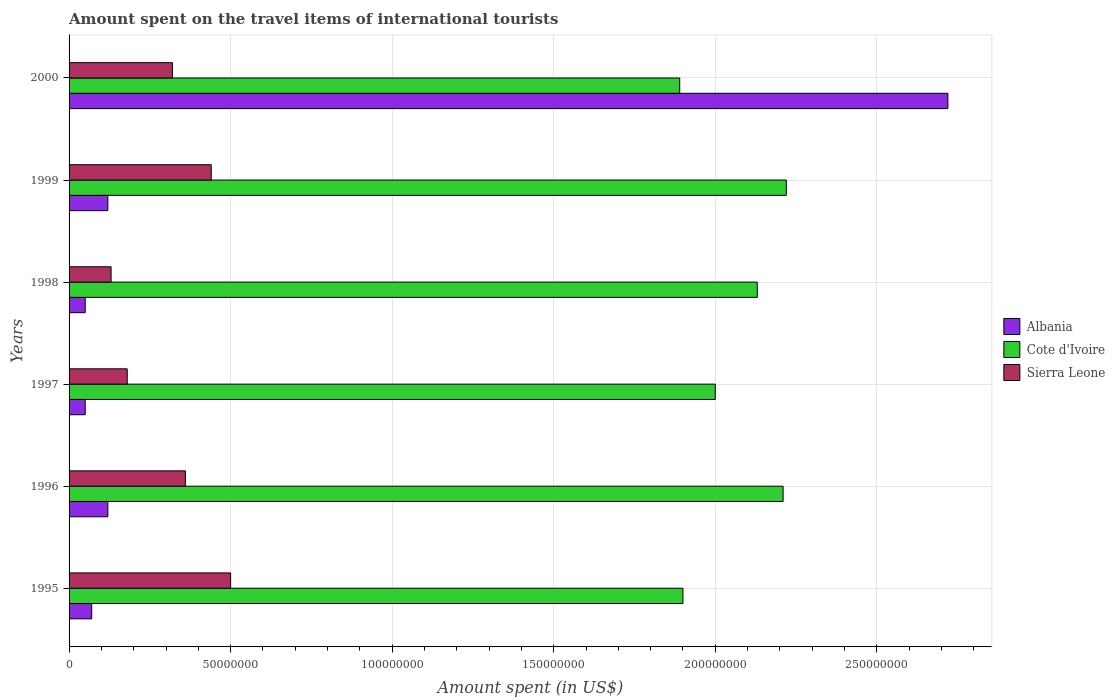How many groups of bars are there?
Your response must be concise. 6. Are the number of bars per tick equal to the number of legend labels?
Your response must be concise. Yes. How many bars are there on the 6th tick from the top?
Ensure brevity in your answer.  3. How many bars are there on the 3rd tick from the bottom?
Provide a short and direct response. 3. What is the label of the 5th group of bars from the top?
Provide a short and direct response. 1996. What is the amount spent on the travel items of international tourists in Cote d'Ivoire in 1998?
Your answer should be compact. 2.13e+08. Across all years, what is the maximum amount spent on the travel items of international tourists in Cote d'Ivoire?
Offer a terse response. 2.22e+08. Across all years, what is the minimum amount spent on the travel items of international tourists in Albania?
Your answer should be compact. 5.00e+06. What is the total amount spent on the travel items of international tourists in Cote d'Ivoire in the graph?
Make the answer very short. 1.24e+09. What is the difference between the amount spent on the travel items of international tourists in Sierra Leone in 1997 and that in 1999?
Give a very brief answer. -2.60e+07. What is the difference between the amount spent on the travel items of international tourists in Albania in 2000 and the amount spent on the travel items of international tourists in Cote d'Ivoire in 1995?
Keep it short and to the point. 8.20e+07. What is the average amount spent on the travel items of international tourists in Cote d'Ivoire per year?
Make the answer very short. 2.06e+08. In the year 1997, what is the difference between the amount spent on the travel items of international tourists in Albania and amount spent on the travel items of international tourists in Cote d'Ivoire?
Keep it short and to the point. -1.95e+08. In how many years, is the amount spent on the travel items of international tourists in Cote d'Ivoire greater than 160000000 US$?
Keep it short and to the point. 6. What is the ratio of the amount spent on the travel items of international tourists in Sierra Leone in 1996 to that in 1999?
Keep it short and to the point. 0.82. Is the amount spent on the travel items of international tourists in Albania in 1996 less than that in 1997?
Your answer should be compact. No. Is the difference between the amount spent on the travel items of international tourists in Albania in 1997 and 1998 greater than the difference between the amount spent on the travel items of international tourists in Cote d'Ivoire in 1997 and 1998?
Give a very brief answer. Yes. What is the difference between the highest and the second highest amount spent on the travel items of international tourists in Albania?
Your answer should be very brief. 2.60e+08. What is the difference between the highest and the lowest amount spent on the travel items of international tourists in Albania?
Give a very brief answer. 2.67e+08. In how many years, is the amount spent on the travel items of international tourists in Cote d'Ivoire greater than the average amount spent on the travel items of international tourists in Cote d'Ivoire taken over all years?
Your answer should be compact. 3. What does the 3rd bar from the top in 1999 represents?
Your answer should be compact. Albania. What does the 3rd bar from the bottom in 2000 represents?
Your response must be concise. Sierra Leone. Is it the case that in every year, the sum of the amount spent on the travel items of international tourists in Sierra Leone and amount spent on the travel items of international tourists in Albania is greater than the amount spent on the travel items of international tourists in Cote d'Ivoire?
Offer a very short reply. No. Are all the bars in the graph horizontal?
Your answer should be compact. Yes. How many years are there in the graph?
Ensure brevity in your answer.  6. Does the graph contain any zero values?
Offer a very short reply. No. How many legend labels are there?
Keep it short and to the point. 3. How are the legend labels stacked?
Your response must be concise. Vertical. What is the title of the graph?
Make the answer very short. Amount spent on the travel items of international tourists. Does "Philippines" appear as one of the legend labels in the graph?
Your answer should be compact. No. What is the label or title of the X-axis?
Your response must be concise. Amount spent (in US$). What is the Amount spent (in US$) of Cote d'Ivoire in 1995?
Provide a short and direct response. 1.90e+08. What is the Amount spent (in US$) of Cote d'Ivoire in 1996?
Give a very brief answer. 2.21e+08. What is the Amount spent (in US$) of Sierra Leone in 1996?
Your response must be concise. 3.60e+07. What is the Amount spent (in US$) in Cote d'Ivoire in 1997?
Make the answer very short. 2.00e+08. What is the Amount spent (in US$) in Sierra Leone in 1997?
Your answer should be compact. 1.80e+07. What is the Amount spent (in US$) in Cote d'Ivoire in 1998?
Ensure brevity in your answer.  2.13e+08. What is the Amount spent (in US$) in Sierra Leone in 1998?
Offer a very short reply. 1.30e+07. What is the Amount spent (in US$) in Albania in 1999?
Your response must be concise. 1.20e+07. What is the Amount spent (in US$) in Cote d'Ivoire in 1999?
Give a very brief answer. 2.22e+08. What is the Amount spent (in US$) in Sierra Leone in 1999?
Ensure brevity in your answer.  4.40e+07. What is the Amount spent (in US$) in Albania in 2000?
Make the answer very short. 2.72e+08. What is the Amount spent (in US$) in Cote d'Ivoire in 2000?
Provide a short and direct response. 1.89e+08. What is the Amount spent (in US$) of Sierra Leone in 2000?
Provide a short and direct response. 3.20e+07. Across all years, what is the maximum Amount spent (in US$) in Albania?
Provide a succinct answer. 2.72e+08. Across all years, what is the maximum Amount spent (in US$) of Cote d'Ivoire?
Give a very brief answer. 2.22e+08. Across all years, what is the minimum Amount spent (in US$) in Cote d'Ivoire?
Your answer should be compact. 1.89e+08. Across all years, what is the minimum Amount spent (in US$) of Sierra Leone?
Ensure brevity in your answer.  1.30e+07. What is the total Amount spent (in US$) in Albania in the graph?
Provide a short and direct response. 3.13e+08. What is the total Amount spent (in US$) of Cote d'Ivoire in the graph?
Your answer should be compact. 1.24e+09. What is the total Amount spent (in US$) of Sierra Leone in the graph?
Make the answer very short. 1.93e+08. What is the difference between the Amount spent (in US$) in Albania in 1995 and that in 1996?
Your response must be concise. -5.00e+06. What is the difference between the Amount spent (in US$) in Cote d'Ivoire in 1995 and that in 1996?
Offer a terse response. -3.10e+07. What is the difference between the Amount spent (in US$) in Sierra Leone in 1995 and that in 1996?
Your answer should be compact. 1.40e+07. What is the difference between the Amount spent (in US$) in Cote d'Ivoire in 1995 and that in 1997?
Keep it short and to the point. -1.00e+07. What is the difference between the Amount spent (in US$) of Sierra Leone in 1995 and that in 1997?
Offer a terse response. 3.20e+07. What is the difference between the Amount spent (in US$) in Albania in 1995 and that in 1998?
Your response must be concise. 2.00e+06. What is the difference between the Amount spent (in US$) in Cote d'Ivoire in 1995 and that in 1998?
Keep it short and to the point. -2.30e+07. What is the difference between the Amount spent (in US$) in Sierra Leone in 1995 and that in 1998?
Offer a very short reply. 3.70e+07. What is the difference between the Amount spent (in US$) in Albania in 1995 and that in 1999?
Ensure brevity in your answer.  -5.00e+06. What is the difference between the Amount spent (in US$) in Cote d'Ivoire in 1995 and that in 1999?
Ensure brevity in your answer.  -3.20e+07. What is the difference between the Amount spent (in US$) in Albania in 1995 and that in 2000?
Give a very brief answer. -2.65e+08. What is the difference between the Amount spent (in US$) of Sierra Leone in 1995 and that in 2000?
Offer a very short reply. 1.80e+07. What is the difference between the Amount spent (in US$) in Albania in 1996 and that in 1997?
Your answer should be very brief. 7.00e+06. What is the difference between the Amount spent (in US$) in Cote d'Ivoire in 1996 and that in 1997?
Offer a terse response. 2.10e+07. What is the difference between the Amount spent (in US$) of Sierra Leone in 1996 and that in 1997?
Provide a short and direct response. 1.80e+07. What is the difference between the Amount spent (in US$) in Albania in 1996 and that in 1998?
Offer a very short reply. 7.00e+06. What is the difference between the Amount spent (in US$) in Sierra Leone in 1996 and that in 1998?
Your answer should be compact. 2.30e+07. What is the difference between the Amount spent (in US$) of Albania in 1996 and that in 1999?
Offer a terse response. 0. What is the difference between the Amount spent (in US$) in Cote d'Ivoire in 1996 and that in 1999?
Keep it short and to the point. -1.00e+06. What is the difference between the Amount spent (in US$) of Sierra Leone in 1996 and that in 1999?
Your response must be concise. -8.00e+06. What is the difference between the Amount spent (in US$) in Albania in 1996 and that in 2000?
Ensure brevity in your answer.  -2.60e+08. What is the difference between the Amount spent (in US$) of Cote d'Ivoire in 1996 and that in 2000?
Your answer should be very brief. 3.20e+07. What is the difference between the Amount spent (in US$) in Sierra Leone in 1996 and that in 2000?
Provide a short and direct response. 4.00e+06. What is the difference between the Amount spent (in US$) in Albania in 1997 and that in 1998?
Give a very brief answer. 0. What is the difference between the Amount spent (in US$) in Cote d'Ivoire in 1997 and that in 1998?
Your answer should be compact. -1.30e+07. What is the difference between the Amount spent (in US$) of Sierra Leone in 1997 and that in 1998?
Your answer should be compact. 5.00e+06. What is the difference between the Amount spent (in US$) of Albania in 1997 and that in 1999?
Your answer should be very brief. -7.00e+06. What is the difference between the Amount spent (in US$) in Cote d'Ivoire in 1997 and that in 1999?
Give a very brief answer. -2.20e+07. What is the difference between the Amount spent (in US$) of Sierra Leone in 1997 and that in 1999?
Offer a very short reply. -2.60e+07. What is the difference between the Amount spent (in US$) in Albania in 1997 and that in 2000?
Your answer should be compact. -2.67e+08. What is the difference between the Amount spent (in US$) in Cote d'Ivoire in 1997 and that in 2000?
Give a very brief answer. 1.10e+07. What is the difference between the Amount spent (in US$) in Sierra Leone in 1997 and that in 2000?
Provide a short and direct response. -1.40e+07. What is the difference between the Amount spent (in US$) of Albania in 1998 and that in 1999?
Offer a terse response. -7.00e+06. What is the difference between the Amount spent (in US$) of Cote d'Ivoire in 1998 and that in 1999?
Make the answer very short. -9.00e+06. What is the difference between the Amount spent (in US$) in Sierra Leone in 1998 and that in 1999?
Ensure brevity in your answer.  -3.10e+07. What is the difference between the Amount spent (in US$) of Albania in 1998 and that in 2000?
Offer a terse response. -2.67e+08. What is the difference between the Amount spent (in US$) in Cote d'Ivoire in 1998 and that in 2000?
Provide a short and direct response. 2.40e+07. What is the difference between the Amount spent (in US$) in Sierra Leone in 1998 and that in 2000?
Keep it short and to the point. -1.90e+07. What is the difference between the Amount spent (in US$) of Albania in 1999 and that in 2000?
Provide a short and direct response. -2.60e+08. What is the difference between the Amount spent (in US$) of Cote d'Ivoire in 1999 and that in 2000?
Provide a succinct answer. 3.30e+07. What is the difference between the Amount spent (in US$) in Sierra Leone in 1999 and that in 2000?
Provide a succinct answer. 1.20e+07. What is the difference between the Amount spent (in US$) of Albania in 1995 and the Amount spent (in US$) of Cote d'Ivoire in 1996?
Ensure brevity in your answer.  -2.14e+08. What is the difference between the Amount spent (in US$) in Albania in 1995 and the Amount spent (in US$) in Sierra Leone in 1996?
Your answer should be very brief. -2.90e+07. What is the difference between the Amount spent (in US$) in Cote d'Ivoire in 1995 and the Amount spent (in US$) in Sierra Leone in 1996?
Provide a short and direct response. 1.54e+08. What is the difference between the Amount spent (in US$) of Albania in 1995 and the Amount spent (in US$) of Cote d'Ivoire in 1997?
Offer a terse response. -1.93e+08. What is the difference between the Amount spent (in US$) in Albania in 1995 and the Amount spent (in US$) in Sierra Leone in 1997?
Your answer should be compact. -1.10e+07. What is the difference between the Amount spent (in US$) in Cote d'Ivoire in 1995 and the Amount spent (in US$) in Sierra Leone in 1997?
Keep it short and to the point. 1.72e+08. What is the difference between the Amount spent (in US$) in Albania in 1995 and the Amount spent (in US$) in Cote d'Ivoire in 1998?
Your answer should be compact. -2.06e+08. What is the difference between the Amount spent (in US$) of Albania in 1995 and the Amount spent (in US$) of Sierra Leone in 1998?
Your answer should be very brief. -6.00e+06. What is the difference between the Amount spent (in US$) in Cote d'Ivoire in 1995 and the Amount spent (in US$) in Sierra Leone in 1998?
Give a very brief answer. 1.77e+08. What is the difference between the Amount spent (in US$) in Albania in 1995 and the Amount spent (in US$) in Cote d'Ivoire in 1999?
Offer a very short reply. -2.15e+08. What is the difference between the Amount spent (in US$) in Albania in 1995 and the Amount spent (in US$) in Sierra Leone in 1999?
Provide a succinct answer. -3.70e+07. What is the difference between the Amount spent (in US$) of Cote d'Ivoire in 1995 and the Amount spent (in US$) of Sierra Leone in 1999?
Make the answer very short. 1.46e+08. What is the difference between the Amount spent (in US$) in Albania in 1995 and the Amount spent (in US$) in Cote d'Ivoire in 2000?
Provide a succinct answer. -1.82e+08. What is the difference between the Amount spent (in US$) of Albania in 1995 and the Amount spent (in US$) of Sierra Leone in 2000?
Give a very brief answer. -2.50e+07. What is the difference between the Amount spent (in US$) of Cote d'Ivoire in 1995 and the Amount spent (in US$) of Sierra Leone in 2000?
Your answer should be very brief. 1.58e+08. What is the difference between the Amount spent (in US$) of Albania in 1996 and the Amount spent (in US$) of Cote d'Ivoire in 1997?
Your answer should be compact. -1.88e+08. What is the difference between the Amount spent (in US$) in Albania in 1996 and the Amount spent (in US$) in Sierra Leone in 1997?
Your answer should be very brief. -6.00e+06. What is the difference between the Amount spent (in US$) of Cote d'Ivoire in 1996 and the Amount spent (in US$) of Sierra Leone in 1997?
Make the answer very short. 2.03e+08. What is the difference between the Amount spent (in US$) of Albania in 1996 and the Amount spent (in US$) of Cote d'Ivoire in 1998?
Give a very brief answer. -2.01e+08. What is the difference between the Amount spent (in US$) in Albania in 1996 and the Amount spent (in US$) in Sierra Leone in 1998?
Offer a terse response. -1.00e+06. What is the difference between the Amount spent (in US$) of Cote d'Ivoire in 1996 and the Amount spent (in US$) of Sierra Leone in 1998?
Make the answer very short. 2.08e+08. What is the difference between the Amount spent (in US$) of Albania in 1996 and the Amount spent (in US$) of Cote d'Ivoire in 1999?
Provide a succinct answer. -2.10e+08. What is the difference between the Amount spent (in US$) in Albania in 1996 and the Amount spent (in US$) in Sierra Leone in 1999?
Offer a terse response. -3.20e+07. What is the difference between the Amount spent (in US$) in Cote d'Ivoire in 1996 and the Amount spent (in US$) in Sierra Leone in 1999?
Offer a terse response. 1.77e+08. What is the difference between the Amount spent (in US$) of Albania in 1996 and the Amount spent (in US$) of Cote d'Ivoire in 2000?
Provide a succinct answer. -1.77e+08. What is the difference between the Amount spent (in US$) of Albania in 1996 and the Amount spent (in US$) of Sierra Leone in 2000?
Your answer should be compact. -2.00e+07. What is the difference between the Amount spent (in US$) in Cote d'Ivoire in 1996 and the Amount spent (in US$) in Sierra Leone in 2000?
Ensure brevity in your answer.  1.89e+08. What is the difference between the Amount spent (in US$) in Albania in 1997 and the Amount spent (in US$) in Cote d'Ivoire in 1998?
Provide a succinct answer. -2.08e+08. What is the difference between the Amount spent (in US$) of Albania in 1997 and the Amount spent (in US$) of Sierra Leone in 1998?
Ensure brevity in your answer.  -8.00e+06. What is the difference between the Amount spent (in US$) in Cote d'Ivoire in 1997 and the Amount spent (in US$) in Sierra Leone in 1998?
Your answer should be compact. 1.87e+08. What is the difference between the Amount spent (in US$) of Albania in 1997 and the Amount spent (in US$) of Cote d'Ivoire in 1999?
Offer a very short reply. -2.17e+08. What is the difference between the Amount spent (in US$) of Albania in 1997 and the Amount spent (in US$) of Sierra Leone in 1999?
Your answer should be compact. -3.90e+07. What is the difference between the Amount spent (in US$) in Cote d'Ivoire in 1997 and the Amount spent (in US$) in Sierra Leone in 1999?
Provide a succinct answer. 1.56e+08. What is the difference between the Amount spent (in US$) in Albania in 1997 and the Amount spent (in US$) in Cote d'Ivoire in 2000?
Provide a succinct answer. -1.84e+08. What is the difference between the Amount spent (in US$) in Albania in 1997 and the Amount spent (in US$) in Sierra Leone in 2000?
Give a very brief answer. -2.70e+07. What is the difference between the Amount spent (in US$) of Cote d'Ivoire in 1997 and the Amount spent (in US$) of Sierra Leone in 2000?
Keep it short and to the point. 1.68e+08. What is the difference between the Amount spent (in US$) of Albania in 1998 and the Amount spent (in US$) of Cote d'Ivoire in 1999?
Give a very brief answer. -2.17e+08. What is the difference between the Amount spent (in US$) of Albania in 1998 and the Amount spent (in US$) of Sierra Leone in 1999?
Provide a short and direct response. -3.90e+07. What is the difference between the Amount spent (in US$) in Cote d'Ivoire in 1998 and the Amount spent (in US$) in Sierra Leone in 1999?
Offer a very short reply. 1.69e+08. What is the difference between the Amount spent (in US$) in Albania in 1998 and the Amount spent (in US$) in Cote d'Ivoire in 2000?
Provide a short and direct response. -1.84e+08. What is the difference between the Amount spent (in US$) of Albania in 1998 and the Amount spent (in US$) of Sierra Leone in 2000?
Offer a very short reply. -2.70e+07. What is the difference between the Amount spent (in US$) in Cote d'Ivoire in 1998 and the Amount spent (in US$) in Sierra Leone in 2000?
Make the answer very short. 1.81e+08. What is the difference between the Amount spent (in US$) in Albania in 1999 and the Amount spent (in US$) in Cote d'Ivoire in 2000?
Make the answer very short. -1.77e+08. What is the difference between the Amount spent (in US$) of Albania in 1999 and the Amount spent (in US$) of Sierra Leone in 2000?
Your answer should be very brief. -2.00e+07. What is the difference between the Amount spent (in US$) of Cote d'Ivoire in 1999 and the Amount spent (in US$) of Sierra Leone in 2000?
Your answer should be compact. 1.90e+08. What is the average Amount spent (in US$) in Albania per year?
Give a very brief answer. 5.22e+07. What is the average Amount spent (in US$) in Cote d'Ivoire per year?
Your response must be concise. 2.06e+08. What is the average Amount spent (in US$) of Sierra Leone per year?
Offer a terse response. 3.22e+07. In the year 1995, what is the difference between the Amount spent (in US$) in Albania and Amount spent (in US$) in Cote d'Ivoire?
Your response must be concise. -1.83e+08. In the year 1995, what is the difference between the Amount spent (in US$) in Albania and Amount spent (in US$) in Sierra Leone?
Provide a succinct answer. -4.30e+07. In the year 1995, what is the difference between the Amount spent (in US$) in Cote d'Ivoire and Amount spent (in US$) in Sierra Leone?
Provide a succinct answer. 1.40e+08. In the year 1996, what is the difference between the Amount spent (in US$) of Albania and Amount spent (in US$) of Cote d'Ivoire?
Offer a very short reply. -2.09e+08. In the year 1996, what is the difference between the Amount spent (in US$) of Albania and Amount spent (in US$) of Sierra Leone?
Provide a succinct answer. -2.40e+07. In the year 1996, what is the difference between the Amount spent (in US$) in Cote d'Ivoire and Amount spent (in US$) in Sierra Leone?
Offer a very short reply. 1.85e+08. In the year 1997, what is the difference between the Amount spent (in US$) in Albania and Amount spent (in US$) in Cote d'Ivoire?
Provide a short and direct response. -1.95e+08. In the year 1997, what is the difference between the Amount spent (in US$) in Albania and Amount spent (in US$) in Sierra Leone?
Give a very brief answer. -1.30e+07. In the year 1997, what is the difference between the Amount spent (in US$) of Cote d'Ivoire and Amount spent (in US$) of Sierra Leone?
Keep it short and to the point. 1.82e+08. In the year 1998, what is the difference between the Amount spent (in US$) in Albania and Amount spent (in US$) in Cote d'Ivoire?
Give a very brief answer. -2.08e+08. In the year 1998, what is the difference between the Amount spent (in US$) of Albania and Amount spent (in US$) of Sierra Leone?
Offer a terse response. -8.00e+06. In the year 1998, what is the difference between the Amount spent (in US$) in Cote d'Ivoire and Amount spent (in US$) in Sierra Leone?
Ensure brevity in your answer.  2.00e+08. In the year 1999, what is the difference between the Amount spent (in US$) of Albania and Amount spent (in US$) of Cote d'Ivoire?
Provide a short and direct response. -2.10e+08. In the year 1999, what is the difference between the Amount spent (in US$) in Albania and Amount spent (in US$) in Sierra Leone?
Make the answer very short. -3.20e+07. In the year 1999, what is the difference between the Amount spent (in US$) in Cote d'Ivoire and Amount spent (in US$) in Sierra Leone?
Your answer should be compact. 1.78e+08. In the year 2000, what is the difference between the Amount spent (in US$) in Albania and Amount spent (in US$) in Cote d'Ivoire?
Make the answer very short. 8.30e+07. In the year 2000, what is the difference between the Amount spent (in US$) in Albania and Amount spent (in US$) in Sierra Leone?
Your answer should be compact. 2.40e+08. In the year 2000, what is the difference between the Amount spent (in US$) in Cote d'Ivoire and Amount spent (in US$) in Sierra Leone?
Give a very brief answer. 1.57e+08. What is the ratio of the Amount spent (in US$) of Albania in 1995 to that in 1996?
Provide a short and direct response. 0.58. What is the ratio of the Amount spent (in US$) in Cote d'Ivoire in 1995 to that in 1996?
Offer a terse response. 0.86. What is the ratio of the Amount spent (in US$) in Sierra Leone in 1995 to that in 1996?
Give a very brief answer. 1.39. What is the ratio of the Amount spent (in US$) of Cote d'Ivoire in 1995 to that in 1997?
Your answer should be very brief. 0.95. What is the ratio of the Amount spent (in US$) in Sierra Leone in 1995 to that in 1997?
Provide a short and direct response. 2.78. What is the ratio of the Amount spent (in US$) in Cote d'Ivoire in 1995 to that in 1998?
Keep it short and to the point. 0.89. What is the ratio of the Amount spent (in US$) of Sierra Leone in 1995 to that in 1998?
Your answer should be compact. 3.85. What is the ratio of the Amount spent (in US$) of Albania in 1995 to that in 1999?
Give a very brief answer. 0.58. What is the ratio of the Amount spent (in US$) of Cote d'Ivoire in 1995 to that in 1999?
Ensure brevity in your answer.  0.86. What is the ratio of the Amount spent (in US$) in Sierra Leone in 1995 to that in 1999?
Offer a very short reply. 1.14. What is the ratio of the Amount spent (in US$) in Albania in 1995 to that in 2000?
Offer a very short reply. 0.03. What is the ratio of the Amount spent (in US$) in Sierra Leone in 1995 to that in 2000?
Offer a terse response. 1.56. What is the ratio of the Amount spent (in US$) in Cote d'Ivoire in 1996 to that in 1997?
Ensure brevity in your answer.  1.1. What is the ratio of the Amount spent (in US$) in Albania in 1996 to that in 1998?
Ensure brevity in your answer.  2.4. What is the ratio of the Amount spent (in US$) of Cote d'Ivoire in 1996 to that in 1998?
Your answer should be very brief. 1.04. What is the ratio of the Amount spent (in US$) in Sierra Leone in 1996 to that in 1998?
Keep it short and to the point. 2.77. What is the ratio of the Amount spent (in US$) of Albania in 1996 to that in 1999?
Your response must be concise. 1. What is the ratio of the Amount spent (in US$) in Sierra Leone in 1996 to that in 1999?
Offer a terse response. 0.82. What is the ratio of the Amount spent (in US$) of Albania in 1996 to that in 2000?
Your answer should be compact. 0.04. What is the ratio of the Amount spent (in US$) in Cote d'Ivoire in 1996 to that in 2000?
Your answer should be very brief. 1.17. What is the ratio of the Amount spent (in US$) in Sierra Leone in 1996 to that in 2000?
Your answer should be very brief. 1.12. What is the ratio of the Amount spent (in US$) in Albania in 1997 to that in 1998?
Ensure brevity in your answer.  1. What is the ratio of the Amount spent (in US$) of Cote d'Ivoire in 1997 to that in 1998?
Your answer should be very brief. 0.94. What is the ratio of the Amount spent (in US$) of Sierra Leone in 1997 to that in 1998?
Provide a succinct answer. 1.38. What is the ratio of the Amount spent (in US$) of Albania in 1997 to that in 1999?
Your response must be concise. 0.42. What is the ratio of the Amount spent (in US$) of Cote d'Ivoire in 1997 to that in 1999?
Provide a succinct answer. 0.9. What is the ratio of the Amount spent (in US$) of Sierra Leone in 1997 to that in 1999?
Make the answer very short. 0.41. What is the ratio of the Amount spent (in US$) of Albania in 1997 to that in 2000?
Offer a very short reply. 0.02. What is the ratio of the Amount spent (in US$) in Cote d'Ivoire in 1997 to that in 2000?
Offer a terse response. 1.06. What is the ratio of the Amount spent (in US$) in Sierra Leone in 1997 to that in 2000?
Keep it short and to the point. 0.56. What is the ratio of the Amount spent (in US$) in Albania in 1998 to that in 1999?
Your answer should be very brief. 0.42. What is the ratio of the Amount spent (in US$) in Cote d'Ivoire in 1998 to that in 1999?
Offer a terse response. 0.96. What is the ratio of the Amount spent (in US$) of Sierra Leone in 1998 to that in 1999?
Your answer should be very brief. 0.3. What is the ratio of the Amount spent (in US$) in Albania in 1998 to that in 2000?
Keep it short and to the point. 0.02. What is the ratio of the Amount spent (in US$) in Cote d'Ivoire in 1998 to that in 2000?
Your answer should be very brief. 1.13. What is the ratio of the Amount spent (in US$) in Sierra Leone in 1998 to that in 2000?
Provide a succinct answer. 0.41. What is the ratio of the Amount spent (in US$) of Albania in 1999 to that in 2000?
Give a very brief answer. 0.04. What is the ratio of the Amount spent (in US$) of Cote d'Ivoire in 1999 to that in 2000?
Provide a short and direct response. 1.17. What is the ratio of the Amount spent (in US$) in Sierra Leone in 1999 to that in 2000?
Provide a succinct answer. 1.38. What is the difference between the highest and the second highest Amount spent (in US$) in Albania?
Give a very brief answer. 2.60e+08. What is the difference between the highest and the lowest Amount spent (in US$) of Albania?
Your response must be concise. 2.67e+08. What is the difference between the highest and the lowest Amount spent (in US$) of Cote d'Ivoire?
Your answer should be very brief. 3.30e+07. What is the difference between the highest and the lowest Amount spent (in US$) in Sierra Leone?
Your answer should be very brief. 3.70e+07. 